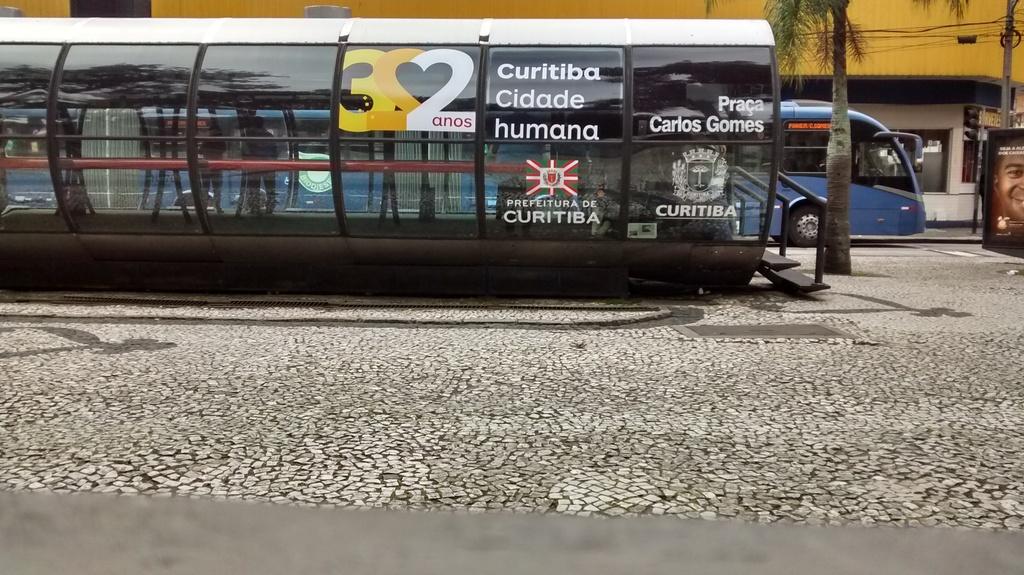What number is shown?
Your answer should be compact. 322. What words are shown?
Make the answer very short. Curitiba cidade humana. 